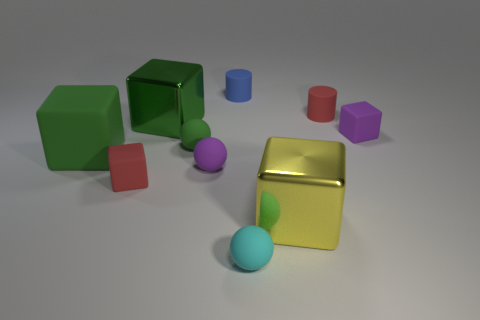There is a small matte object in front of the tiny rubber block to the left of the large yellow metal cube; what number of green rubber things are to the left of it?
Keep it short and to the point. 2. Are there any other things of the same color as the big matte cube?
Offer a terse response. Yes. There is a green object to the right of the green metal thing; is it the same size as the large yellow thing?
Your answer should be very brief. No. There is a rubber object right of the tiny red matte cylinder; what number of big metal blocks are behind it?
Your response must be concise. 1. There is a big metal thing to the left of the purple matte object on the left side of the blue rubber cylinder; is there a small cube to the right of it?
Keep it short and to the point. Yes. What is the material of the tiny purple thing that is the same shape as the yellow thing?
Offer a very short reply. Rubber. Is there anything else that has the same material as the purple cube?
Your answer should be compact. Yes. Do the purple block and the small red thing that is behind the tiny purple ball have the same material?
Offer a terse response. Yes. There is a tiny red rubber object that is behind the rubber cube to the left of the small red rubber cube; what shape is it?
Offer a terse response. Cylinder. How many tiny objects are either purple objects or gray rubber spheres?
Give a very brief answer. 2. 